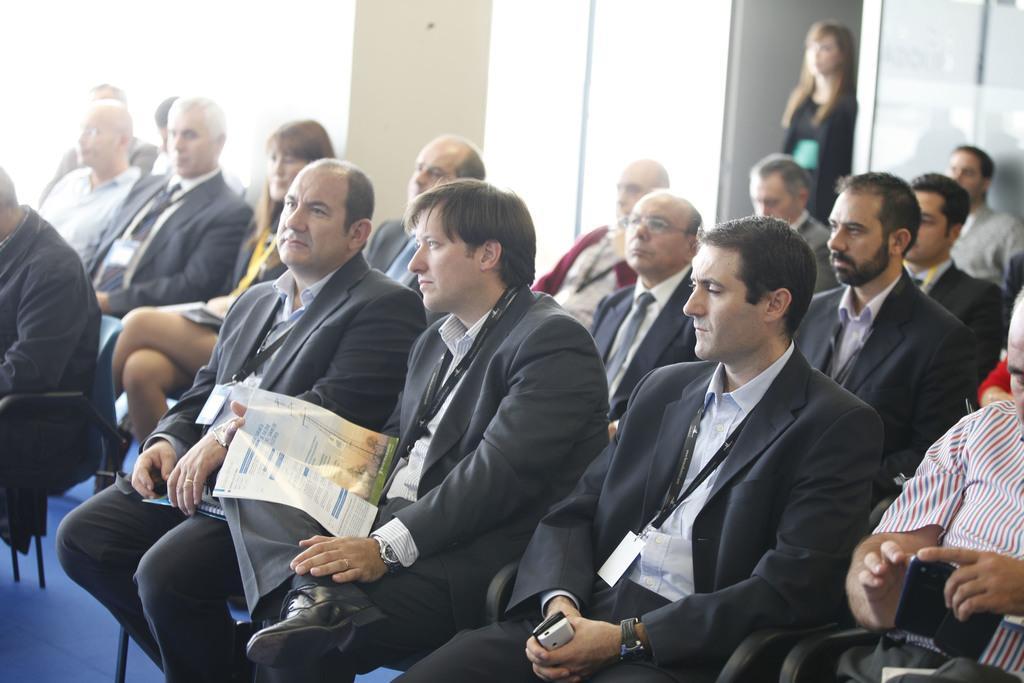Please provide a concise description of this image. In the image we can see there are people sitting on the chairs and there are people wearing id cards in the neck. There are two people holding mobile phones in their hand and there is a person holding paper. Behind there is a woman standing and background of the image is little blurred. 